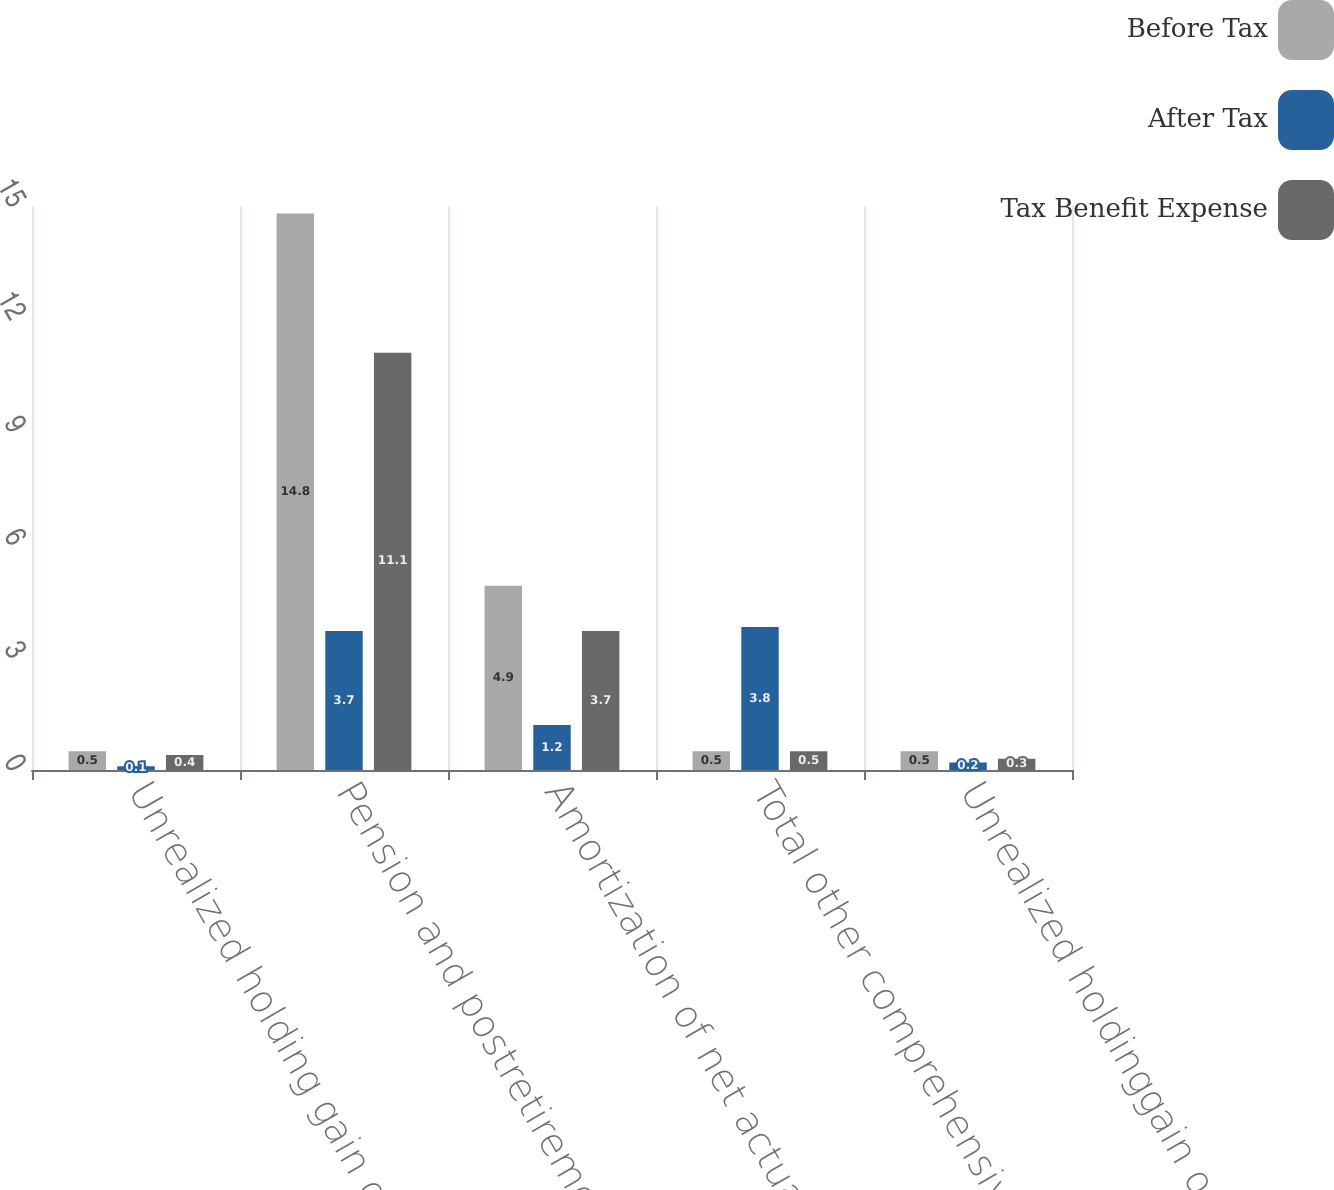Convert chart. <chart><loc_0><loc_0><loc_500><loc_500><stacked_bar_chart><ecel><fcel>Unrealized holding gain on<fcel>Pension and postretirement<fcel>Amortization of net actuarial<fcel>Total other comprehensive<fcel>Unrealized holdinggain on<nl><fcel>Before Tax<fcel>0.5<fcel>14.8<fcel>4.9<fcel>0.5<fcel>0.5<nl><fcel>After Tax<fcel>0.1<fcel>3.7<fcel>1.2<fcel>3.8<fcel>0.2<nl><fcel>Tax Benefit Expense<fcel>0.4<fcel>11.1<fcel>3.7<fcel>0.5<fcel>0.3<nl></chart> 